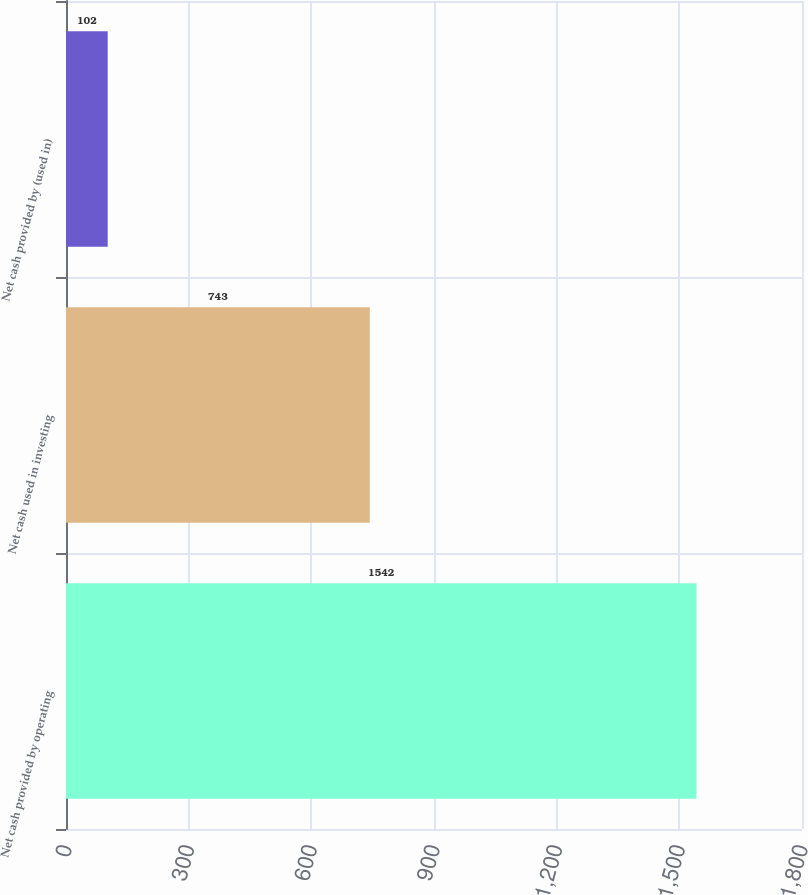<chart> <loc_0><loc_0><loc_500><loc_500><bar_chart><fcel>Net cash provided by operating<fcel>Net cash used in investing<fcel>Net cash provided by (used in)<nl><fcel>1542<fcel>743<fcel>102<nl></chart> 